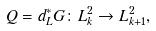<formula> <loc_0><loc_0><loc_500><loc_500>Q = d _ { L } ^ { * } G \colon L ^ { 2 } _ { k } \rightarrow L ^ { 2 } _ { k + 1 } ,</formula> 